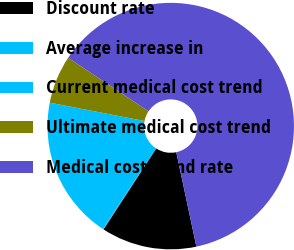Convert chart. <chart><loc_0><loc_0><loc_500><loc_500><pie_chart><fcel>Discount rate<fcel>Average increase in<fcel>Current medical cost trend<fcel>Ultimate medical cost trend<fcel>Medical cost trend rate<nl><fcel>12.53%<fcel>0.09%<fcel>18.76%<fcel>6.31%<fcel>62.3%<nl></chart> 